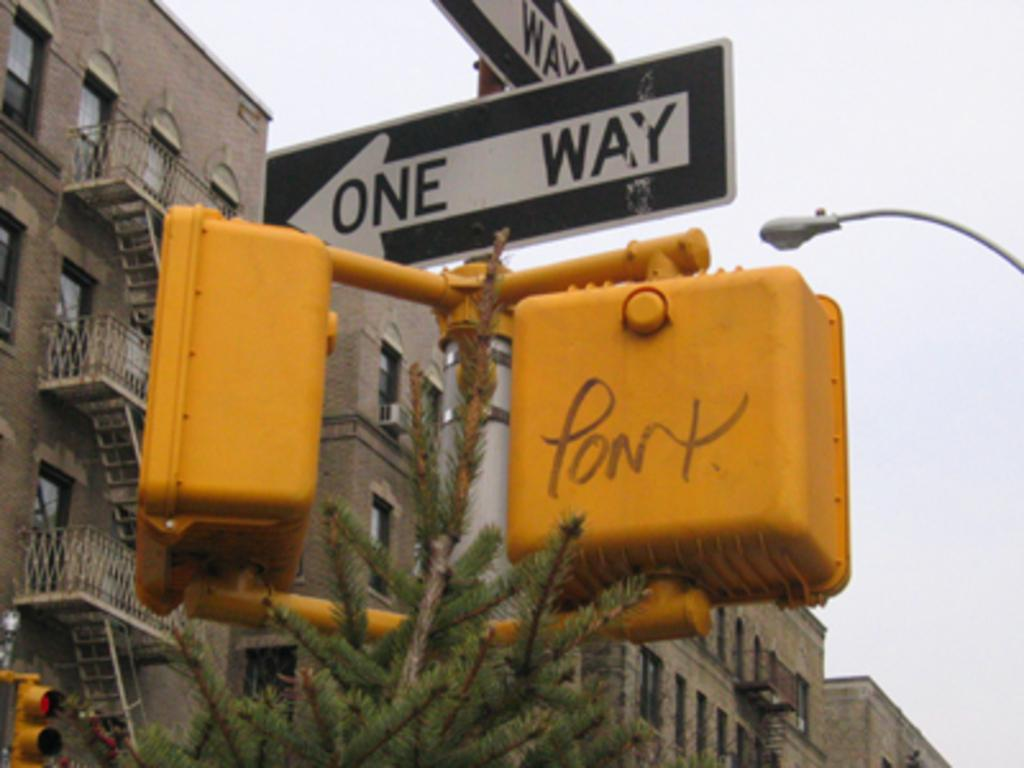<image>
Provide a brief description of the given image. Two one way signs are on top of a crosswalk signal. 